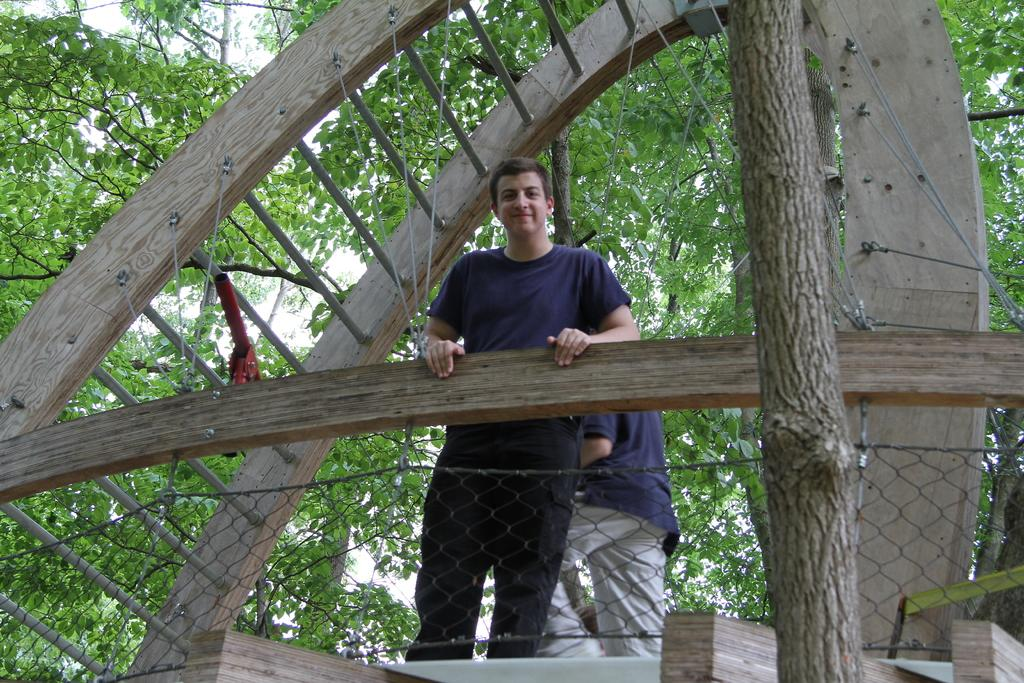How many people are in the image? There are two people in the image. Where are the people located in the image? The people are standing on a bridge. What type of material is visible in the image? There is a mesh visible in the image. What can be seen in the background of the image? There are trees and the sky visible in the background of the image. What type of floor can be seen under the bridge in the image? There is no floor visible under the bridge in the image; it is suspended above a body of water. 